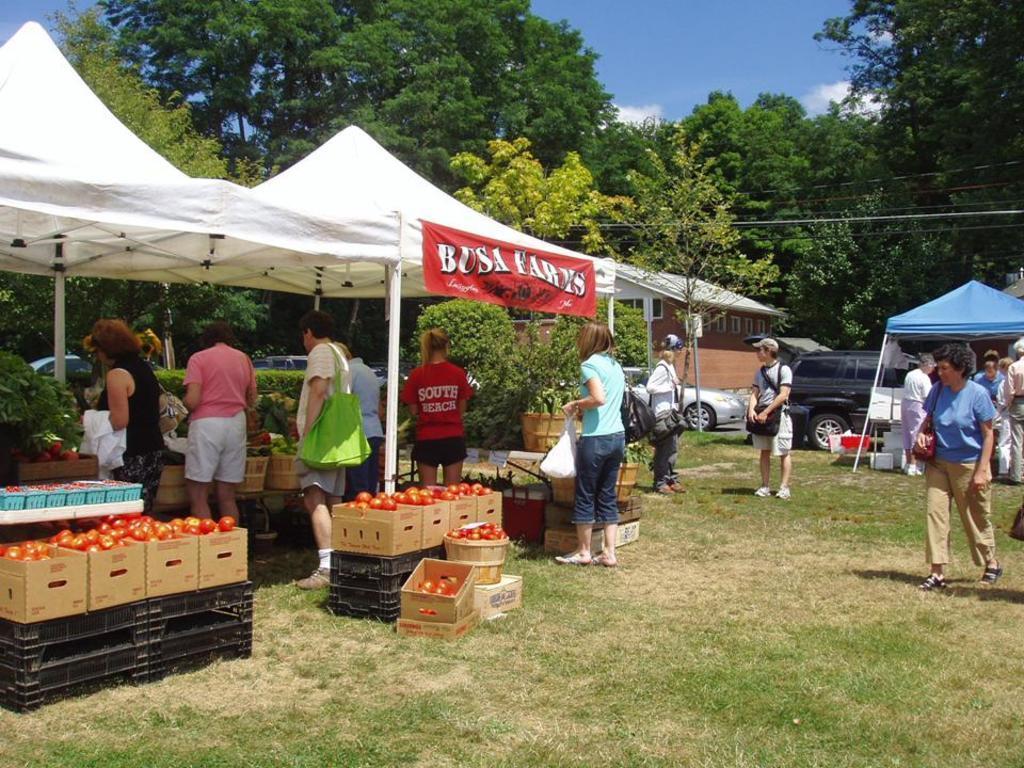Could you give a brief overview of what you see in this image? In the image we can see there are people standing on the ground and the ground is covered with grass. There are tomatoes kept on the boxes and there are tents. There is banner kept on the tent and there are cars parked on the road. Behind there are trees and there is a cloudy sky. 